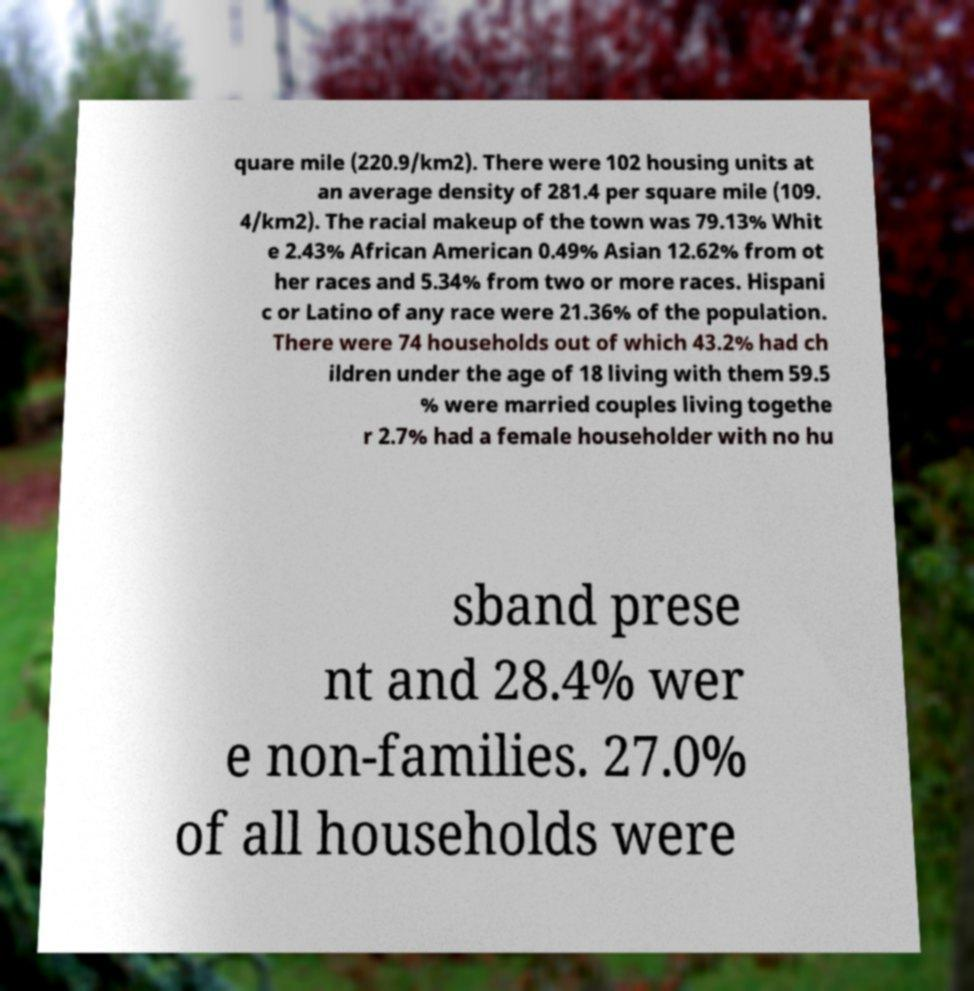For documentation purposes, I need the text within this image transcribed. Could you provide that? quare mile (220.9/km2). There were 102 housing units at an average density of 281.4 per square mile (109. 4/km2). The racial makeup of the town was 79.13% Whit e 2.43% African American 0.49% Asian 12.62% from ot her races and 5.34% from two or more races. Hispani c or Latino of any race were 21.36% of the population. There were 74 households out of which 43.2% had ch ildren under the age of 18 living with them 59.5 % were married couples living togethe r 2.7% had a female householder with no hu sband prese nt and 28.4% wer e non-families. 27.0% of all households were 